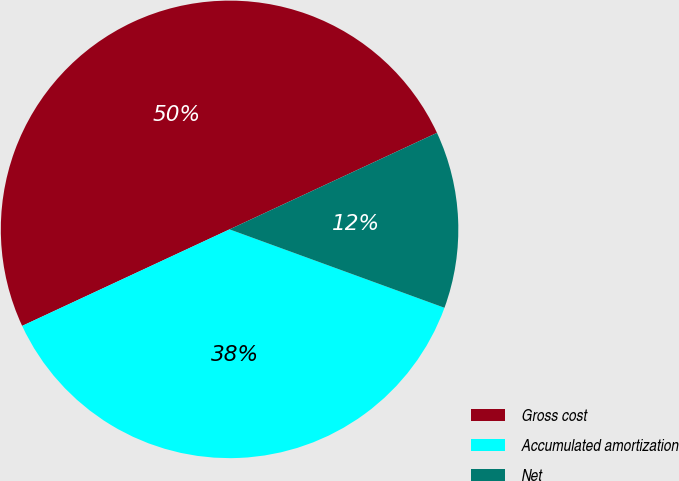Convert chart to OTSL. <chart><loc_0><loc_0><loc_500><loc_500><pie_chart><fcel>Gross cost<fcel>Accumulated amortization<fcel>Net<nl><fcel>50.0%<fcel>37.5%<fcel>12.5%<nl></chart> 